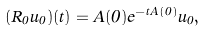<formula> <loc_0><loc_0><loc_500><loc_500>( R _ { 0 } u _ { 0 } ) ( t ) = A ( 0 ) e ^ { - t A ( 0 ) } u _ { 0 } ,</formula> 